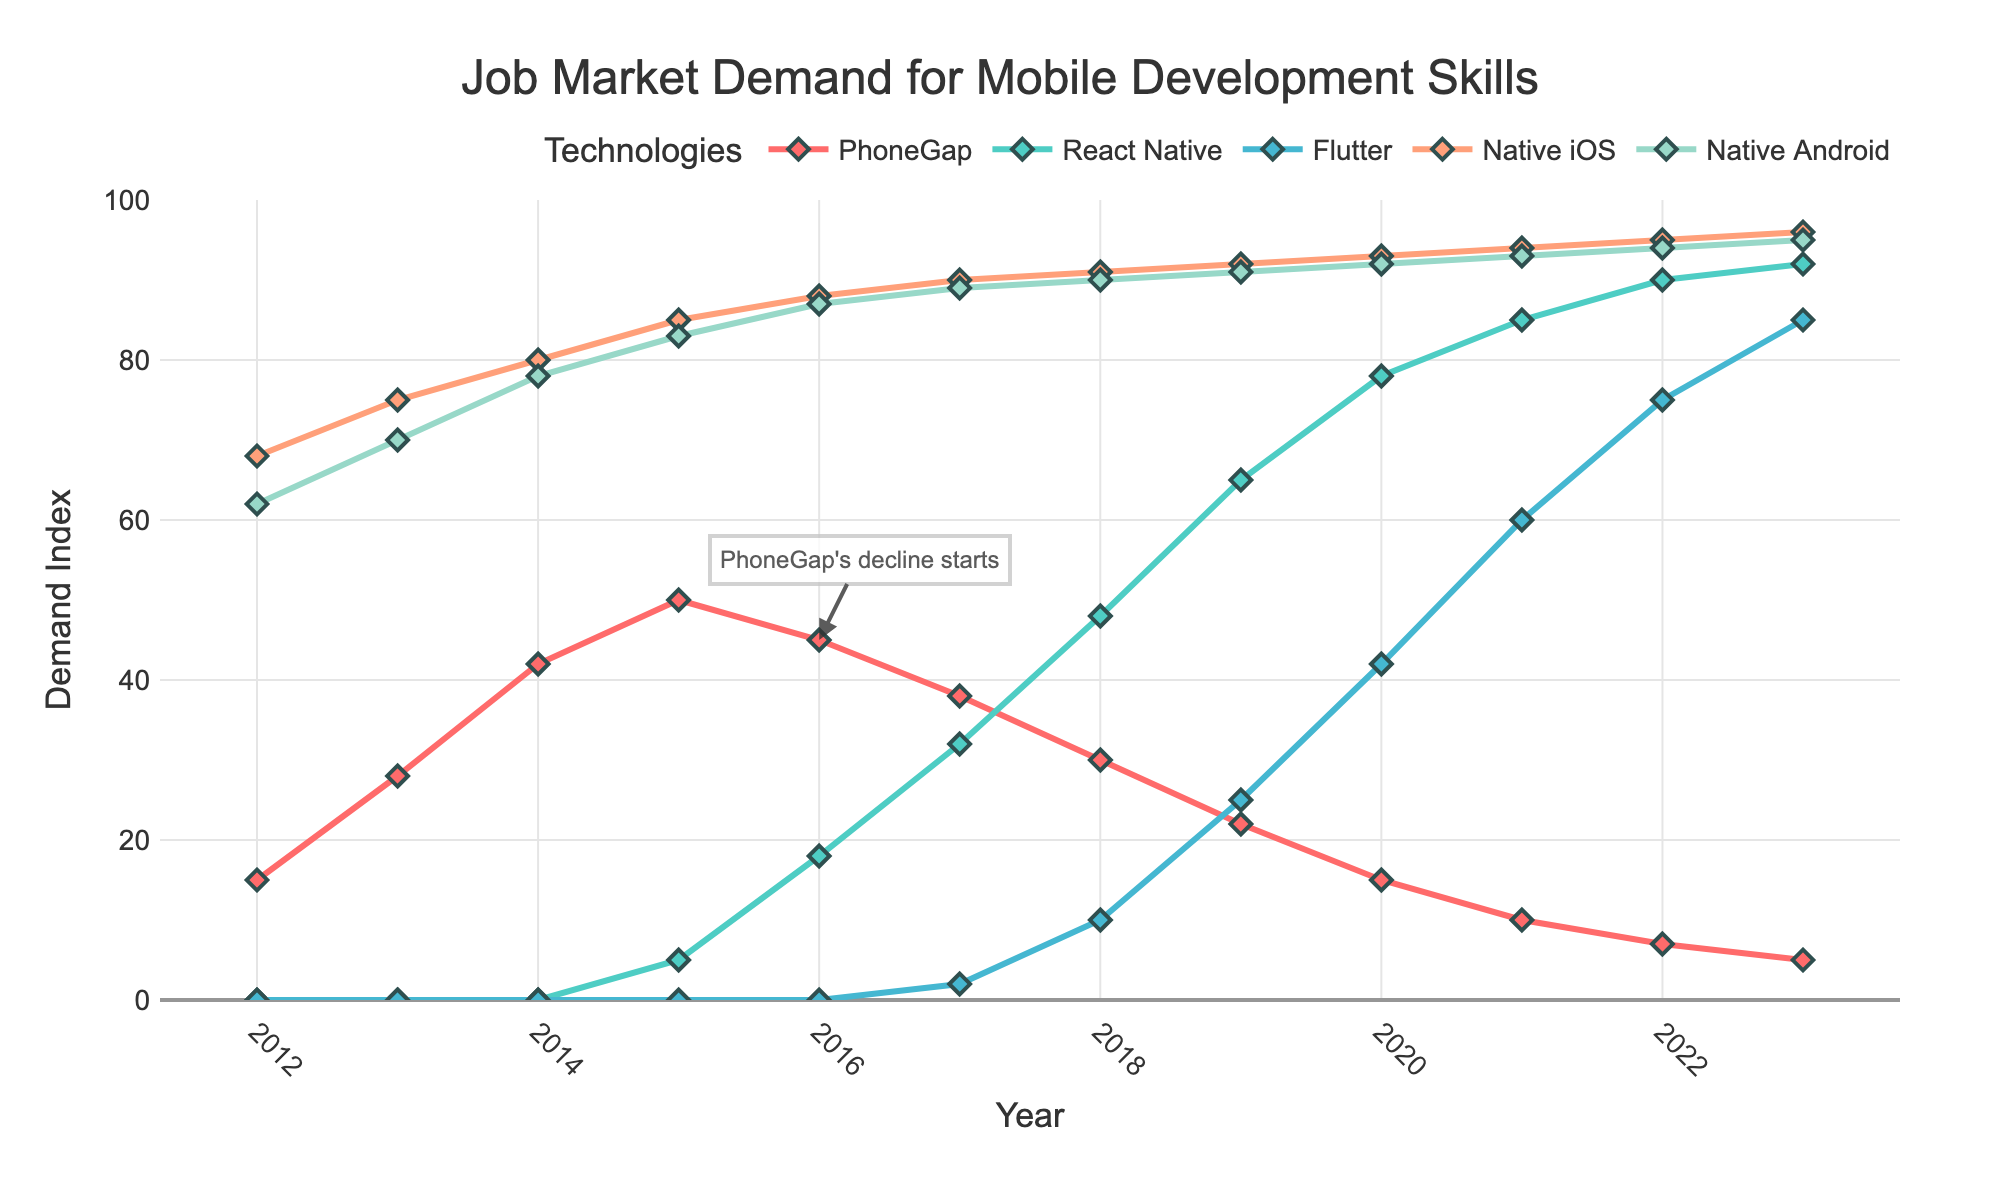What's the overall trend for PhoneGap's job market demand from 2012 to 2023? By looking at the plot, we can see that PhoneGap's demand started at 15 in 2012, peaked around 2015 with a value of 50, and then gradually declined to a value of 5 by 2023.
Answer: Declining How does React Native's job market demand in 2023 compare to its demand in 2017? In 2017, React Native had a demand value of 32. By 2023, this demand had increased to 92. We see an increase of 92 - 32 = 60.
Answer: Increased by 60 In which year did Flutter's job market demand surpass 20? Observing the plot, Flutter's demand is greater than 20 starting from 2019, with a value of 25.
Answer: 2019 Which technology had the highest job market demand in 2015? For 2015, the highest demand values on the plot are Native iOS and Native Android, both peaking at around 85 and 83 respectively. Comparing, Native iOS is slightly higher.
Answer: Native iOS Calculate the average job market demand for Native Android between 2012 and 2023. Summing the values: 62+70+78+83+87+89+90+91+92+93+94+95 = 1024. There are 12 values, so the average is 1024/12.
Answer: 85.33 Which technology shows the most prominent growth trend from 2016 to 2023? By comparing the slopes of the lines from 2016 to 2023, React Native shows the most significant rise from 18 in 2016 to 92 in 2023.
Answer: React Native When did the job market demand for PhoneGap begin to decline significantly? According to the annotation in the figure and the line slope changes, the significant decline began in 2016, where it dropped from 50 in 2015 to 45 in 2016.
Answer: 2016 What is the difference in demand between Flutter and Native iOS in 2019? In 2019, Flutter's demand is 25 and Native iOS's demand is 92. The difference is 92 - 25.
Answer: 67 Which mobile development skill showed the least variation in job market demand over the given period? By assessing the stability of the plotted lines, Native iOS and Native Android show consistent demand levels. Among the two, Native iOS fluctuated the least, staying within a small range around 90-96.
Answer: Native iOS Is there any year when PhoneGap's demand was higher than React Native's? From looking at the plot, before 2015, React Native had a value of 0, and PhoneGap had values from 15 to 50. Therefore, any year before 2016 qualifies (i.e., 2012-2015).
Answer: Yes, 2012-2015 